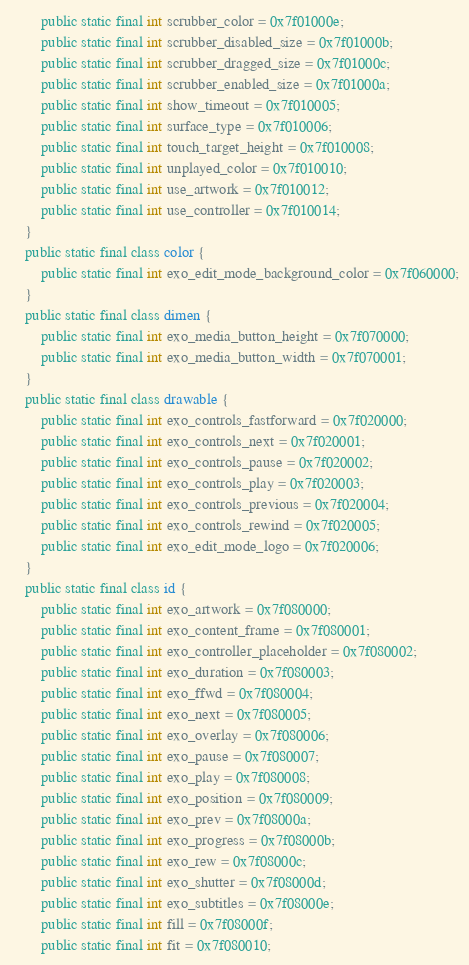Convert code to text. <code><loc_0><loc_0><loc_500><loc_500><_Java_>        public static final int scrubber_color = 0x7f01000e;
        public static final int scrubber_disabled_size = 0x7f01000b;
        public static final int scrubber_dragged_size = 0x7f01000c;
        public static final int scrubber_enabled_size = 0x7f01000a;
        public static final int show_timeout = 0x7f010005;
        public static final int surface_type = 0x7f010006;
        public static final int touch_target_height = 0x7f010008;
        public static final int unplayed_color = 0x7f010010;
        public static final int use_artwork = 0x7f010012;
        public static final int use_controller = 0x7f010014;
    }
    public static final class color {
        public static final int exo_edit_mode_background_color = 0x7f060000;
    }
    public static final class dimen {
        public static final int exo_media_button_height = 0x7f070000;
        public static final int exo_media_button_width = 0x7f070001;
    }
    public static final class drawable {
        public static final int exo_controls_fastforward = 0x7f020000;
        public static final int exo_controls_next = 0x7f020001;
        public static final int exo_controls_pause = 0x7f020002;
        public static final int exo_controls_play = 0x7f020003;
        public static final int exo_controls_previous = 0x7f020004;
        public static final int exo_controls_rewind = 0x7f020005;
        public static final int exo_edit_mode_logo = 0x7f020006;
    }
    public static final class id {
        public static final int exo_artwork = 0x7f080000;
        public static final int exo_content_frame = 0x7f080001;
        public static final int exo_controller_placeholder = 0x7f080002;
        public static final int exo_duration = 0x7f080003;
        public static final int exo_ffwd = 0x7f080004;
        public static final int exo_next = 0x7f080005;
        public static final int exo_overlay = 0x7f080006;
        public static final int exo_pause = 0x7f080007;
        public static final int exo_play = 0x7f080008;
        public static final int exo_position = 0x7f080009;
        public static final int exo_prev = 0x7f08000a;
        public static final int exo_progress = 0x7f08000b;
        public static final int exo_rew = 0x7f08000c;
        public static final int exo_shutter = 0x7f08000d;
        public static final int exo_subtitles = 0x7f08000e;
        public static final int fill = 0x7f08000f;
        public static final int fit = 0x7f080010;</code> 